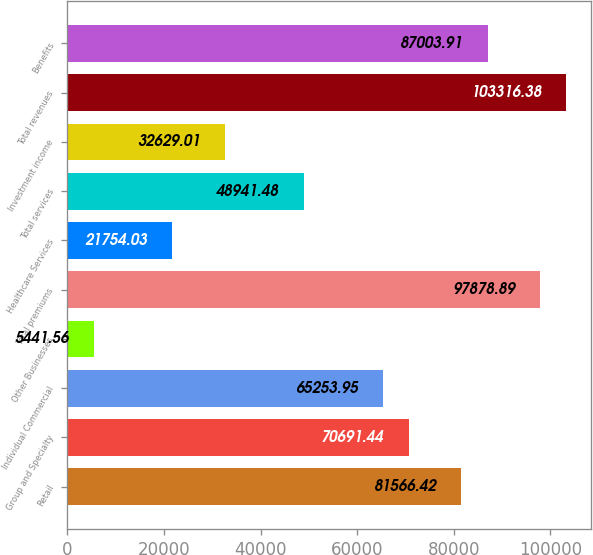<chart> <loc_0><loc_0><loc_500><loc_500><bar_chart><fcel>Retail<fcel>Group and Specialty<fcel>Individual Commercial<fcel>Other Businesses<fcel>Total premiums<fcel>Healthcare Services<fcel>Total services<fcel>Investment income<fcel>Total revenues<fcel>Benefits<nl><fcel>81566.4<fcel>70691.4<fcel>65253.9<fcel>5441.56<fcel>97878.9<fcel>21754<fcel>48941.5<fcel>32629<fcel>103316<fcel>87003.9<nl></chart> 